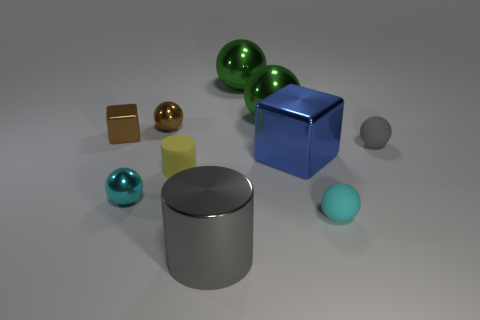Is the shape of the tiny yellow object the same as the big gray object? Yes, the shape of the tiny yellow object, which is a cube, is indeed the same as the larger gray object, confirming that they both have the geometry of a cube with six faces, twelve edges, and eight vertices. 